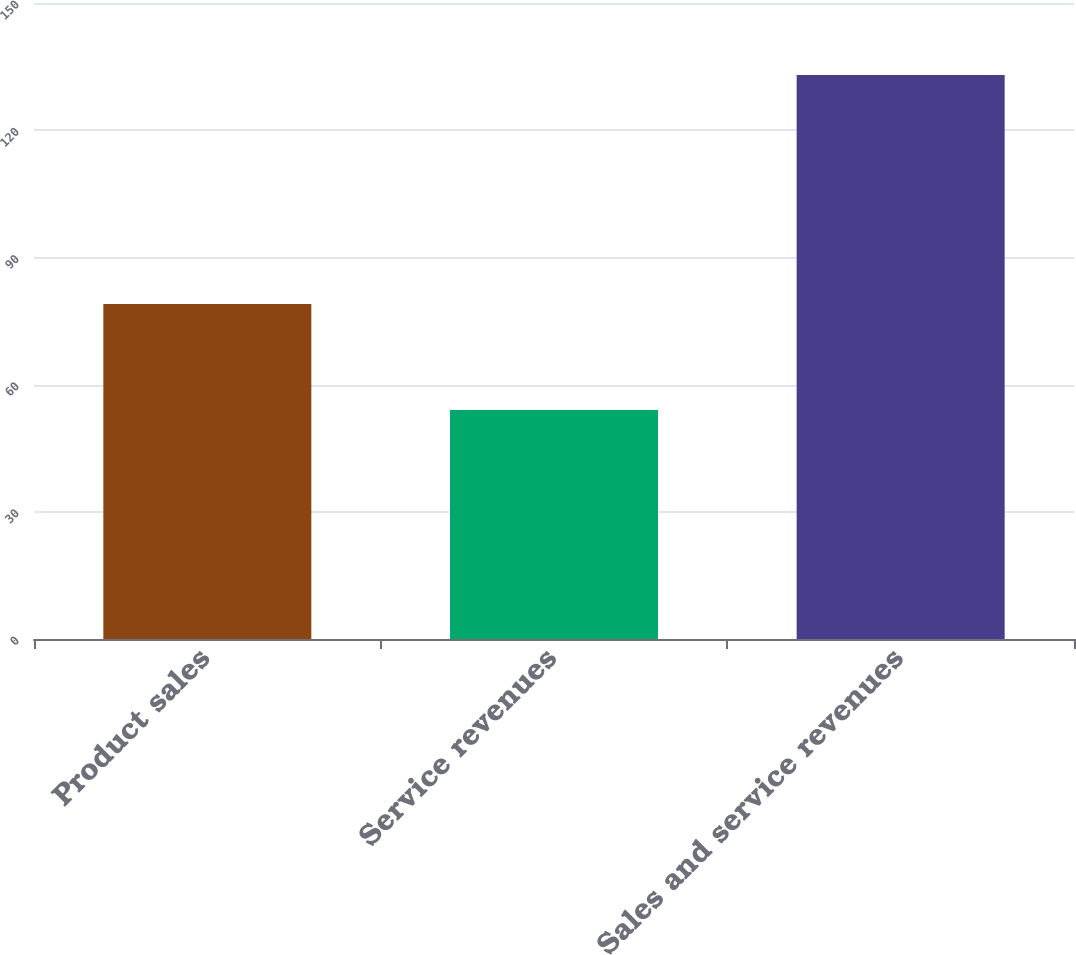Convert chart to OTSL. <chart><loc_0><loc_0><loc_500><loc_500><bar_chart><fcel>Product sales<fcel>Service revenues<fcel>Sales and service revenues<nl><fcel>79<fcel>54<fcel>133<nl></chart> 